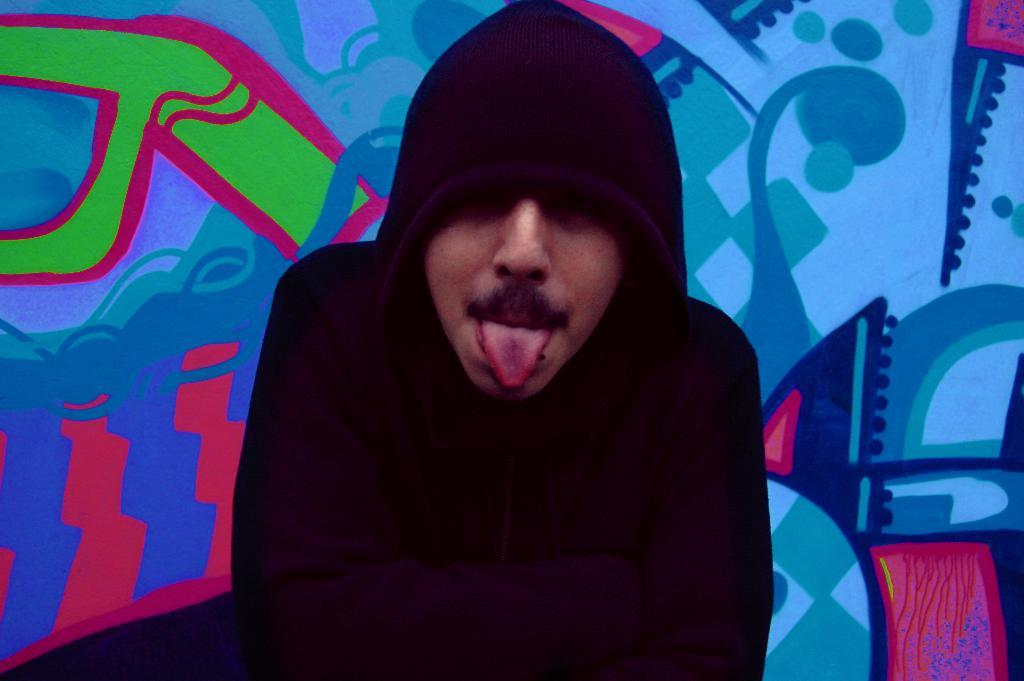Who is present in the image? There is a man in the image. What is the man wearing? The man is wearing a hoodie. What can be seen in the background of the image? There is a colorful wall in the background of the image. What type of bed is visible in the image? There is no bed present in the image. 